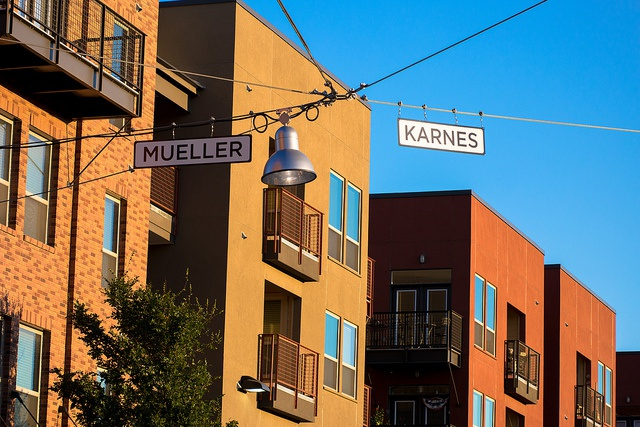Describe the objects in this image and their specific colors. I can see various objects in this image with different colors. 